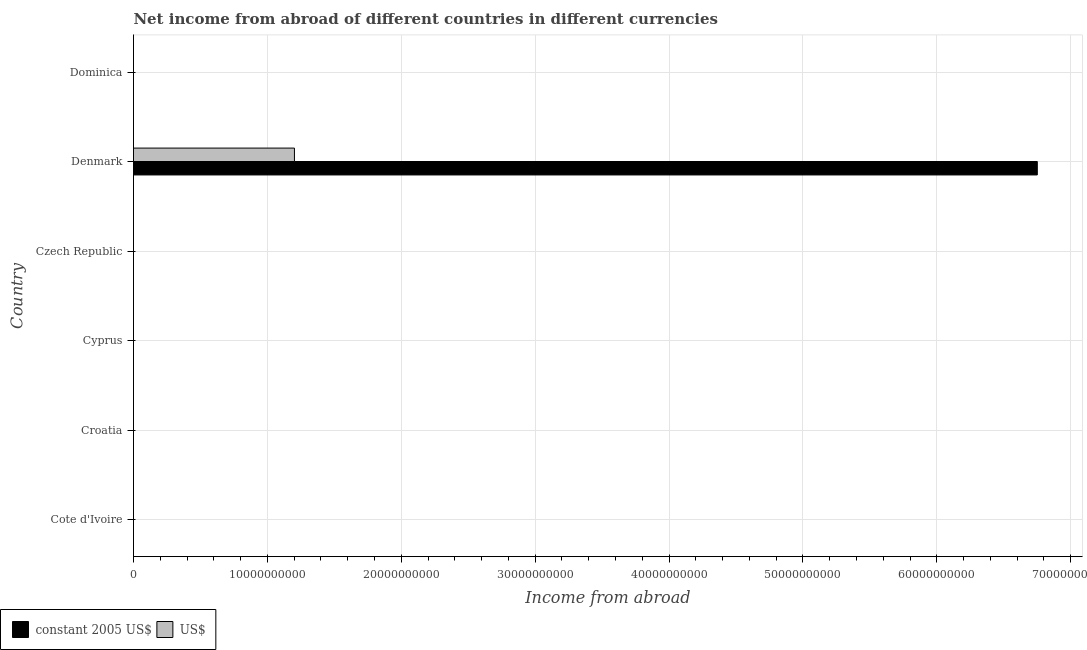How many different coloured bars are there?
Offer a very short reply. 2. Are the number of bars per tick equal to the number of legend labels?
Ensure brevity in your answer.  No. Are the number of bars on each tick of the Y-axis equal?
Your answer should be very brief. No. How many bars are there on the 6th tick from the top?
Provide a succinct answer. 0. What is the label of the 1st group of bars from the top?
Your answer should be very brief. Dominica. In how many cases, is the number of bars for a given country not equal to the number of legend labels?
Offer a terse response. 5. Across all countries, what is the maximum income from abroad in constant 2005 us$?
Your answer should be compact. 6.75e+1. In which country was the income from abroad in constant 2005 us$ maximum?
Keep it short and to the point. Denmark. What is the total income from abroad in constant 2005 us$ in the graph?
Keep it short and to the point. 6.75e+1. What is the difference between the income from abroad in us$ in Czech Republic and the income from abroad in constant 2005 us$ in Denmark?
Your answer should be compact. -6.75e+1. What is the average income from abroad in constant 2005 us$ per country?
Provide a short and direct response. 1.13e+1. What is the difference between the income from abroad in constant 2005 us$ and income from abroad in us$ in Denmark?
Offer a terse response. 5.55e+1. What is the difference between the highest and the lowest income from abroad in us$?
Your answer should be very brief. 1.20e+1. In how many countries, is the income from abroad in constant 2005 us$ greater than the average income from abroad in constant 2005 us$ taken over all countries?
Make the answer very short. 1. How many bars are there?
Offer a very short reply. 2. What is the difference between two consecutive major ticks on the X-axis?
Your answer should be compact. 1.00e+1. Are the values on the major ticks of X-axis written in scientific E-notation?
Ensure brevity in your answer.  No. How many legend labels are there?
Offer a terse response. 2. How are the legend labels stacked?
Provide a succinct answer. Horizontal. What is the title of the graph?
Your answer should be very brief. Net income from abroad of different countries in different currencies. What is the label or title of the X-axis?
Provide a succinct answer. Income from abroad. What is the label or title of the Y-axis?
Offer a very short reply. Country. What is the Income from abroad in US$ in Croatia?
Keep it short and to the point. 0. What is the Income from abroad of constant 2005 US$ in Cyprus?
Provide a short and direct response. 0. What is the Income from abroad in US$ in Cyprus?
Offer a very short reply. 0. What is the Income from abroad in constant 2005 US$ in Denmark?
Keep it short and to the point. 6.75e+1. What is the Income from abroad of US$ in Denmark?
Ensure brevity in your answer.  1.20e+1. Across all countries, what is the maximum Income from abroad of constant 2005 US$?
Give a very brief answer. 6.75e+1. Across all countries, what is the maximum Income from abroad of US$?
Keep it short and to the point. 1.20e+1. What is the total Income from abroad in constant 2005 US$ in the graph?
Make the answer very short. 6.75e+1. What is the total Income from abroad of US$ in the graph?
Make the answer very short. 1.20e+1. What is the average Income from abroad in constant 2005 US$ per country?
Make the answer very short. 1.13e+1. What is the average Income from abroad of US$ per country?
Keep it short and to the point. 2.00e+09. What is the difference between the Income from abroad in constant 2005 US$ and Income from abroad in US$ in Denmark?
Your answer should be compact. 5.55e+1. What is the difference between the highest and the lowest Income from abroad in constant 2005 US$?
Offer a very short reply. 6.75e+1. What is the difference between the highest and the lowest Income from abroad of US$?
Ensure brevity in your answer.  1.20e+1. 